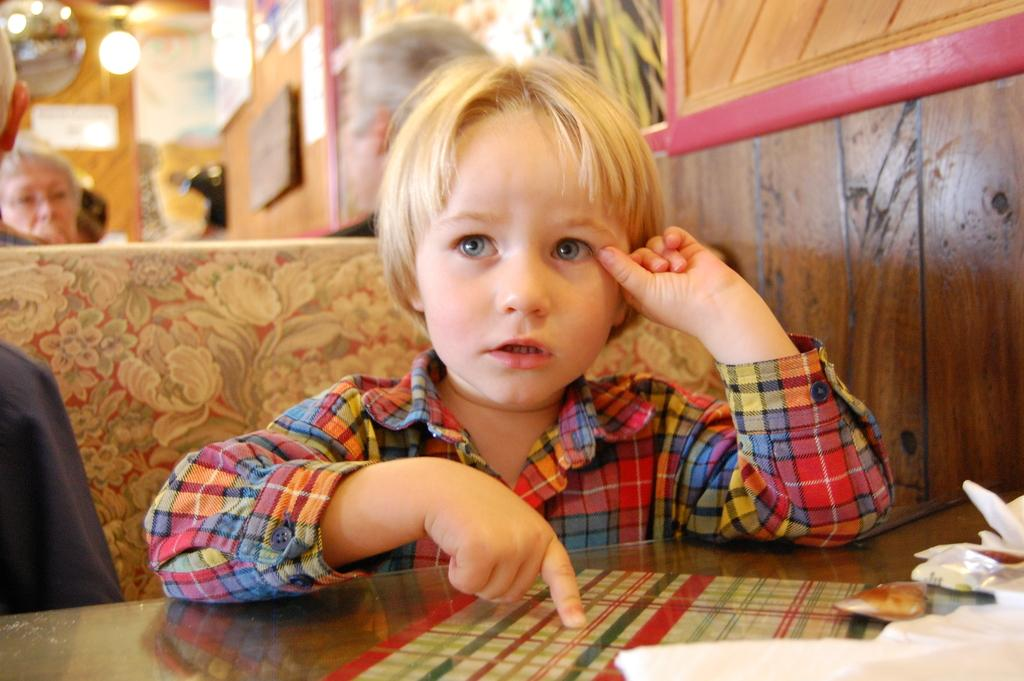What is the kid doing in the image? The kid is sitting on a chair in the image. Where is the kid located in relation to the table? The kid is at a table in the image. Are there any other people present in the image? Yes, there are people sitting on chairs behind the kid. Can you describe the lighting in the image? There is light in the image. What type of celery is being discussed at the meeting in the image? There is no meeting or celery present in the image; it features a kid sitting at a table with people behind them. What country is the kid from in the image? The country of origin of the kid in the image cannot be determined from the image itself. 